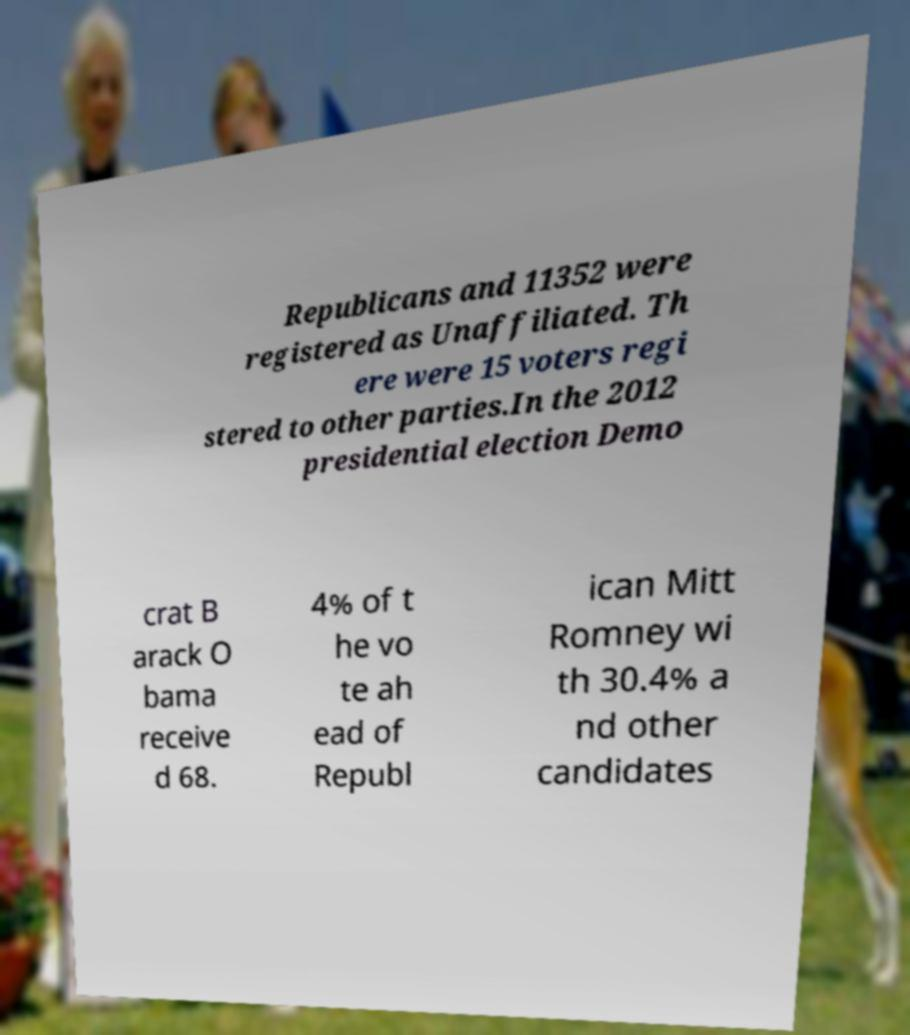I need the written content from this picture converted into text. Can you do that? Republicans and 11352 were registered as Unaffiliated. Th ere were 15 voters regi stered to other parties.In the 2012 presidential election Demo crat B arack O bama receive d 68. 4% of t he vo te ah ead of Republ ican Mitt Romney wi th 30.4% a nd other candidates 